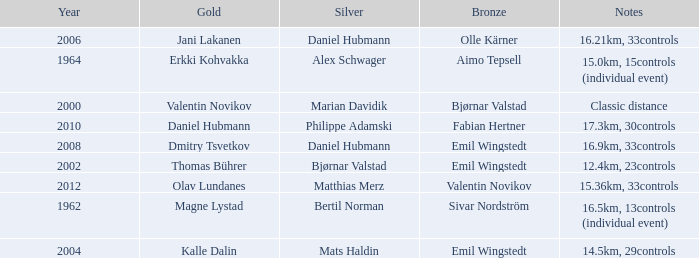WHAT IS THE SILVER WITH A YEAR OF 1962? Bertil Norman. 